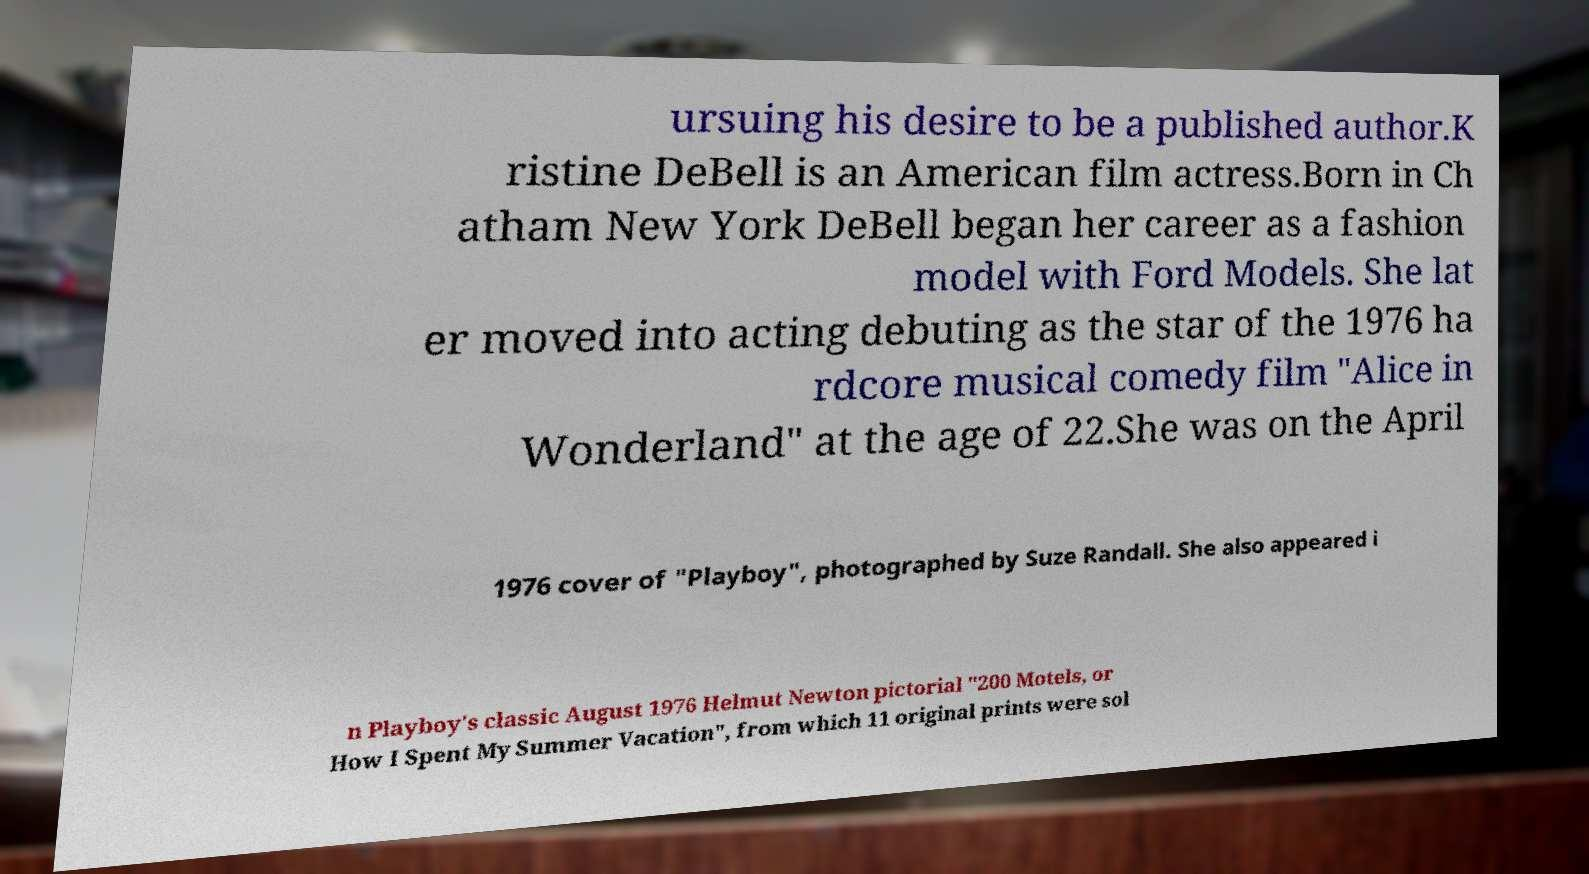Could you extract and type out the text from this image? ursuing his desire to be a published author.K ristine DeBell is an American film actress.Born in Ch atham New York DeBell began her career as a fashion model with Ford Models. She lat er moved into acting debuting as the star of the 1976 ha rdcore musical comedy film "Alice in Wonderland" at the age of 22.She was on the April 1976 cover of "Playboy", photographed by Suze Randall. She also appeared i n Playboy's classic August 1976 Helmut Newton pictorial "200 Motels, or How I Spent My Summer Vacation", from which 11 original prints were sol 